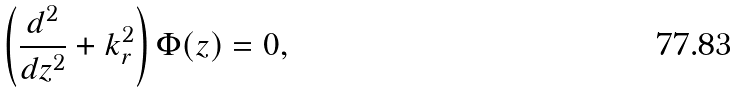Convert formula to latex. <formula><loc_0><loc_0><loc_500><loc_500>\left ( \frac { d ^ { 2 } } { d z ^ { 2 } } + k _ { r } ^ { 2 } \right ) \Phi ( z ) = 0 ,</formula> 